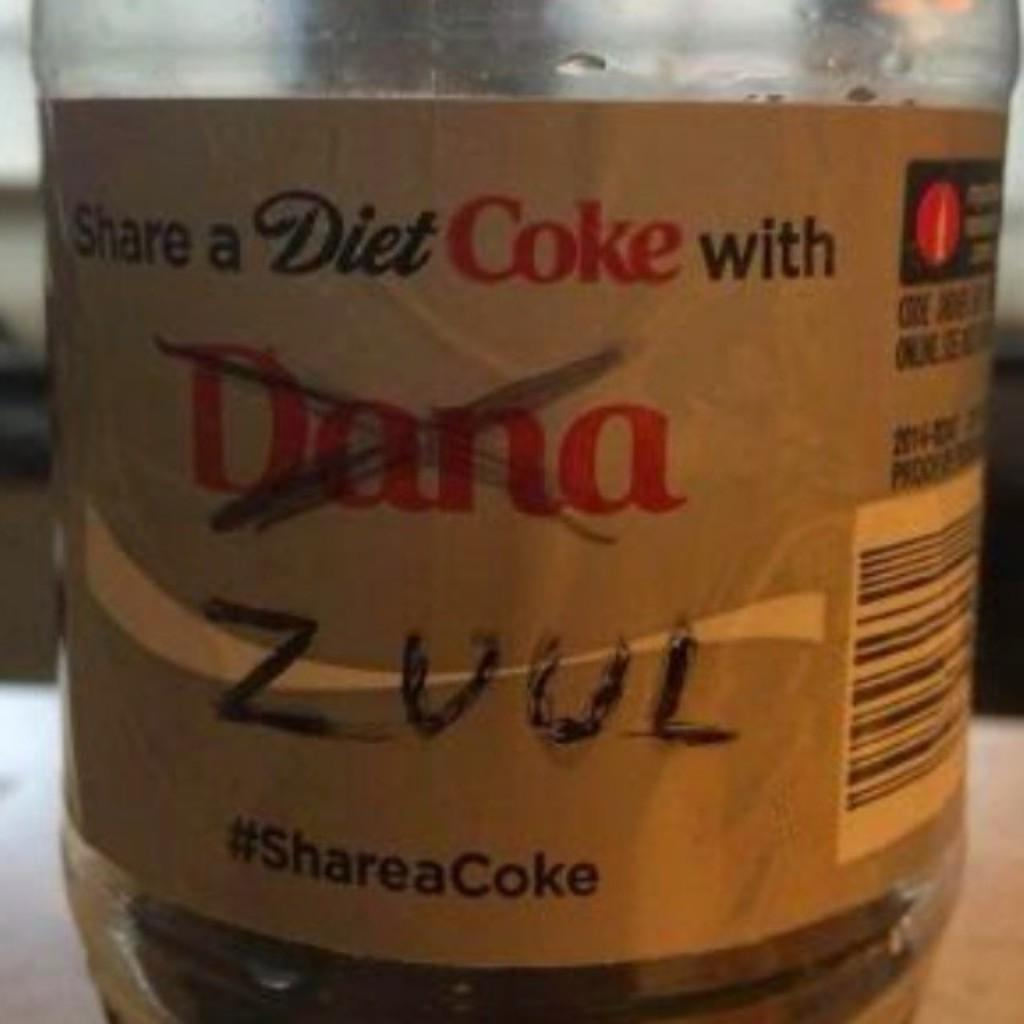<image>
Write a terse but informative summary of the picture. A Diet Coke label on which one name has been crossed out and another written in. 